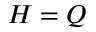Convert formula to latex. <formula><loc_0><loc_0><loc_500><loc_500>H = Q</formula> 